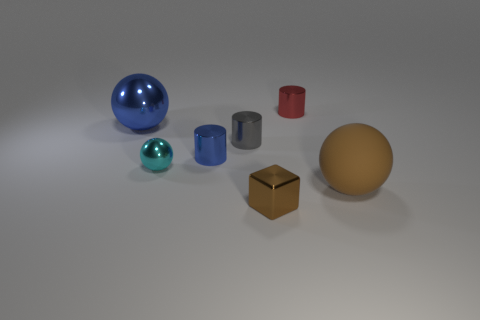Do the tiny cube and the big matte thing have the same color?
Your answer should be compact. Yes. What number of other objects are the same size as the brown metallic block?
Your answer should be compact. 4. Is there any other thing of the same color as the large rubber sphere?
Your answer should be compact. Yes. There is a large rubber object that is the same color as the shiny block; what is its shape?
Ensure brevity in your answer.  Sphere. The small blue metal thing has what shape?
Give a very brief answer. Cylinder. Is the number of blue cylinders behind the red shiny cylinder less than the number of tiny brown metallic cubes?
Provide a succinct answer. Yes. Is there a small red object of the same shape as the gray metal object?
Provide a succinct answer. Yes. There is a gray shiny object that is the same size as the block; what is its shape?
Offer a terse response. Cylinder. How many objects are big purple rubber spheres or tiny brown things?
Your answer should be very brief. 1. Are there any small gray cubes?
Make the answer very short. No. 